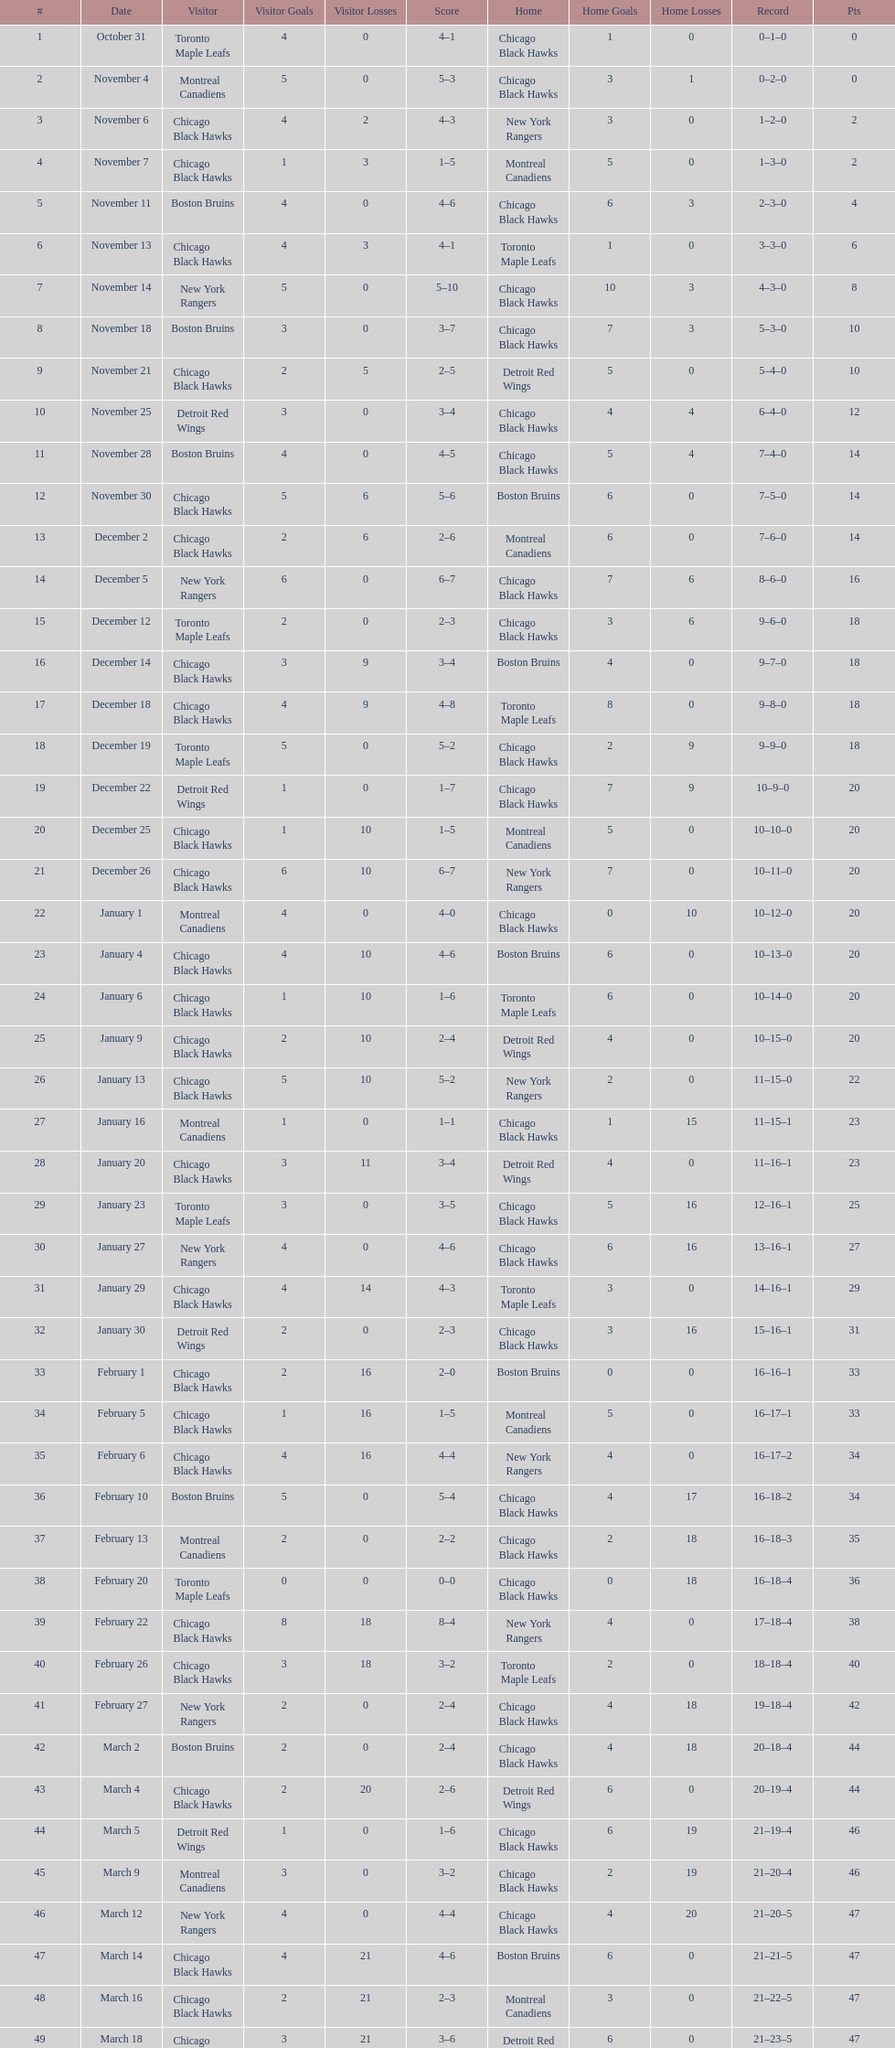How many total games did they win? 22. 